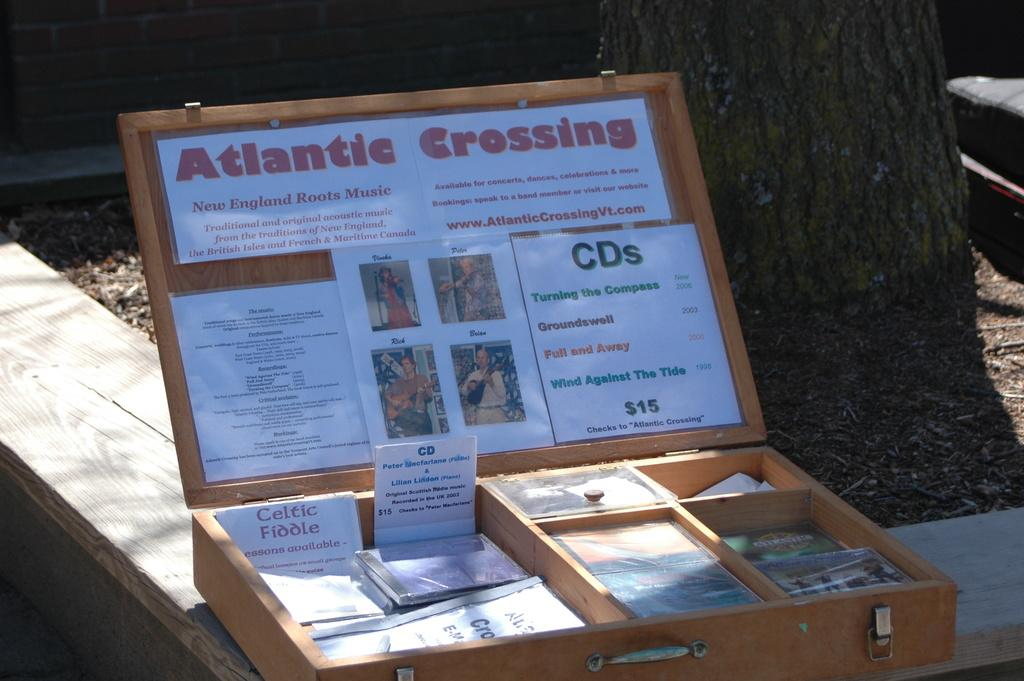<image>
Present a compact description of the photo's key features. An open wooden box with the words Atlantic Crossing on the top 